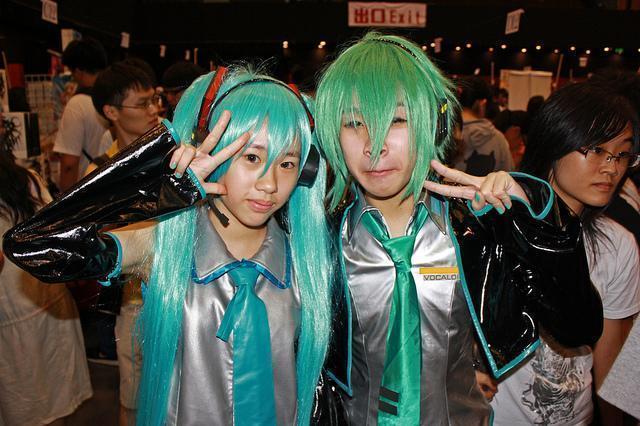What hand gesture are the two doing?
Indicate the correct choice and explain in the format: 'Answer: answer
Rationale: rationale.'
Options: Hang ten, thumbs up, devil horns, peace sign. Answer: peace sign.
Rationale: They are making the peace sign with their fingers. 